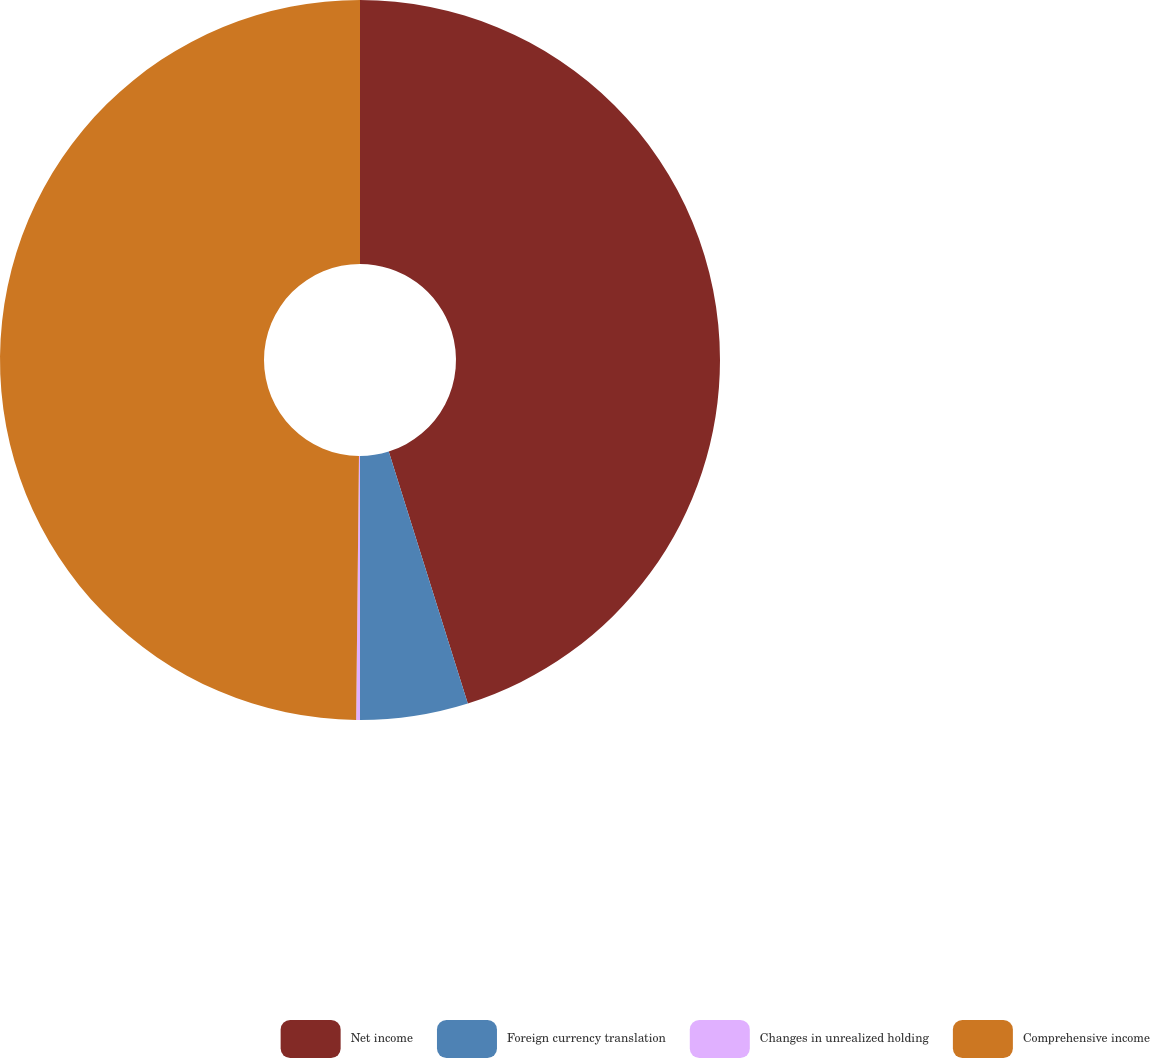<chart> <loc_0><loc_0><loc_500><loc_500><pie_chart><fcel>Net income<fcel>Foreign currency translation<fcel>Changes in unrealized holding<fcel>Comprehensive income<nl><fcel>45.16%<fcel>4.84%<fcel>0.17%<fcel>49.83%<nl></chart> 